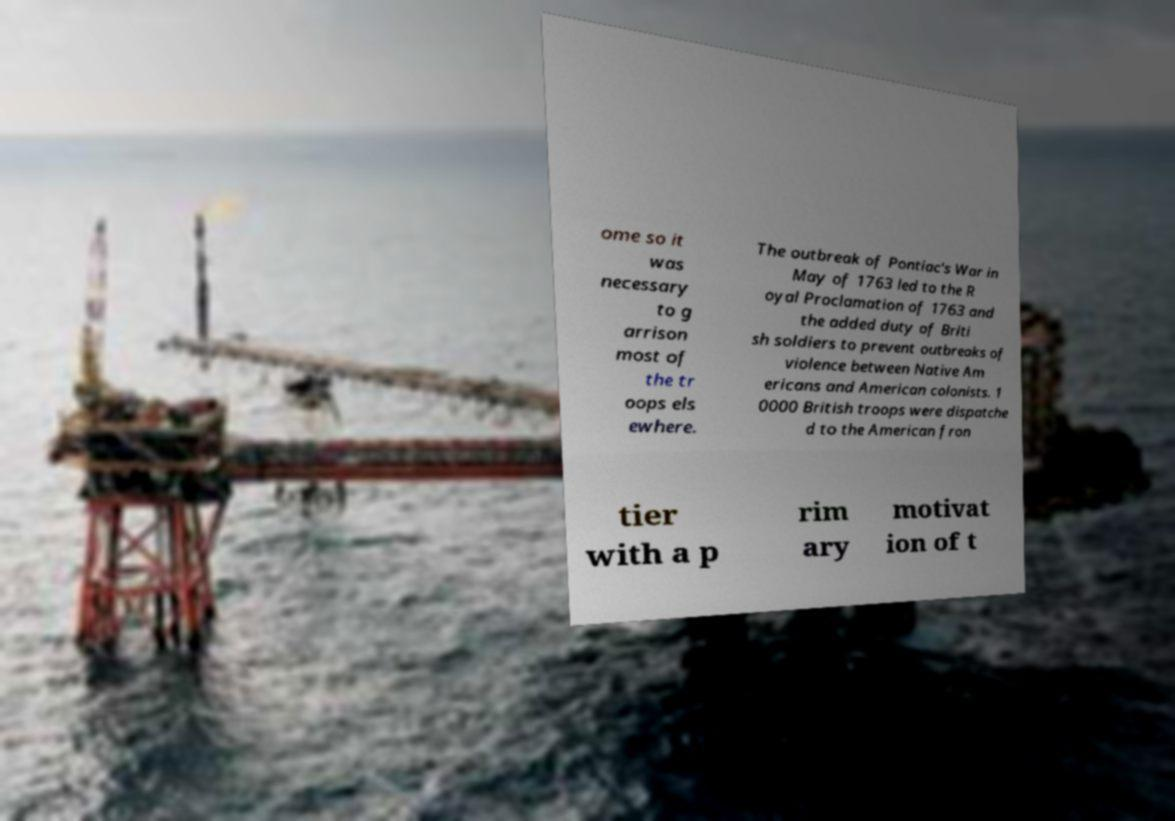Could you extract and type out the text from this image? ome so it was necessary to g arrison most of the tr oops els ewhere. The outbreak of Pontiac's War in May of 1763 led to the R oyal Proclamation of 1763 and the added duty of Briti sh soldiers to prevent outbreaks of violence between Native Am ericans and American colonists. 1 0000 British troops were dispatche d to the American fron tier with a p rim ary motivat ion of t 